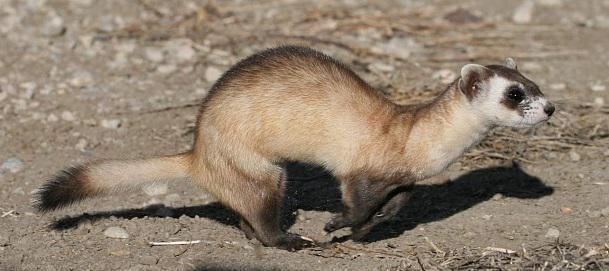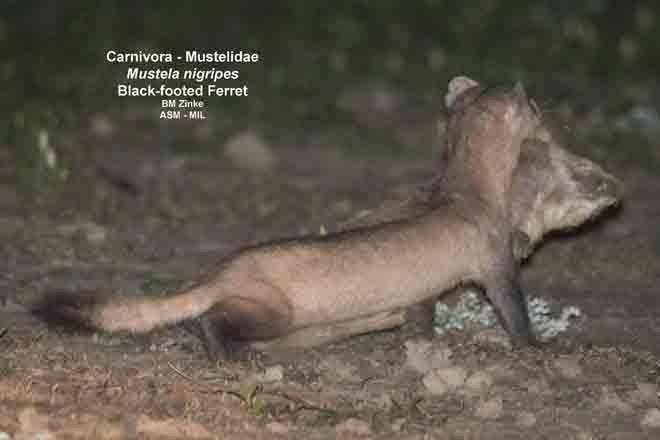The first image is the image on the left, the second image is the image on the right. Given the left and right images, does the statement "There is a pair of ferrets in one image." hold true? Answer yes or no. Yes. The first image is the image on the left, the second image is the image on the right. Considering the images on both sides, is "The body of at least two ferrets are facing directly at the camera" valid? Answer yes or no. No. 